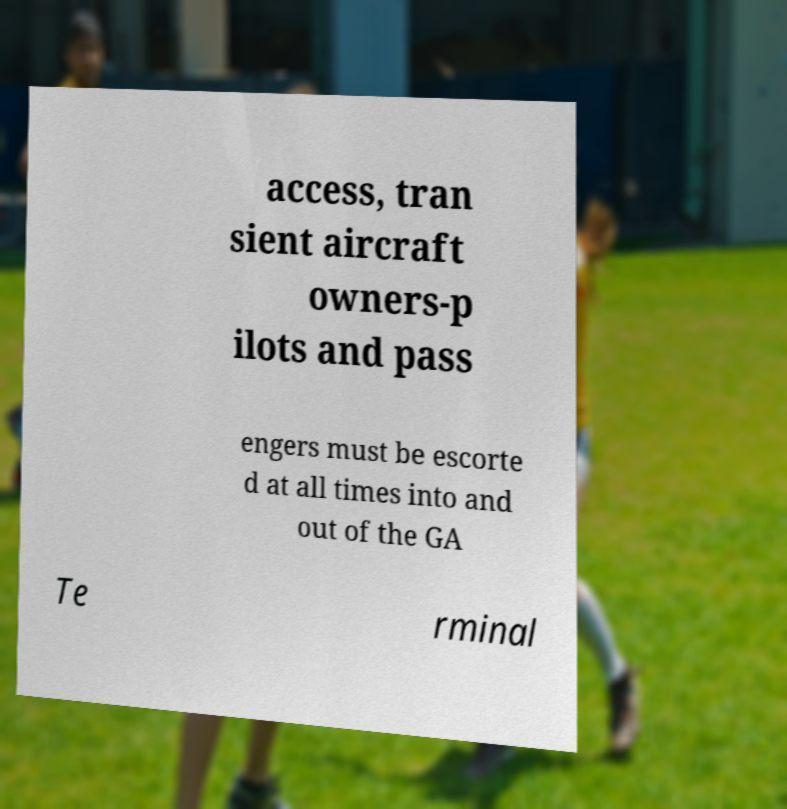For documentation purposes, I need the text within this image transcribed. Could you provide that? access, tran sient aircraft owners-p ilots and pass engers must be escorte d at all times into and out of the GA Te rminal 